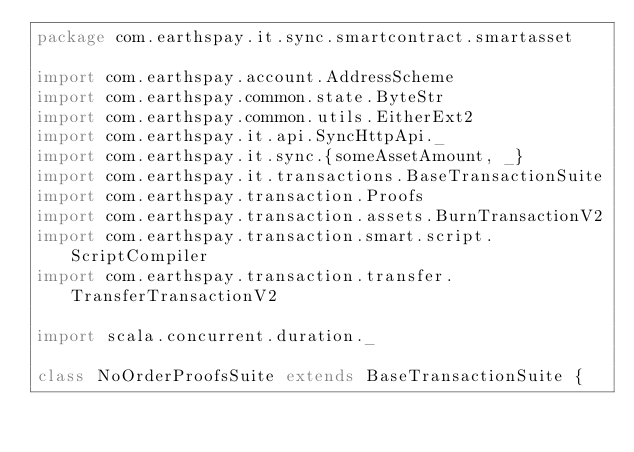Convert code to text. <code><loc_0><loc_0><loc_500><loc_500><_Scala_>package com.earthspay.it.sync.smartcontract.smartasset

import com.earthspay.account.AddressScheme
import com.earthspay.common.state.ByteStr
import com.earthspay.common.utils.EitherExt2
import com.earthspay.it.api.SyncHttpApi._
import com.earthspay.it.sync.{someAssetAmount, _}
import com.earthspay.it.transactions.BaseTransactionSuite
import com.earthspay.transaction.Proofs
import com.earthspay.transaction.assets.BurnTransactionV2
import com.earthspay.transaction.smart.script.ScriptCompiler
import com.earthspay.transaction.transfer.TransferTransactionV2

import scala.concurrent.duration._

class NoOrderProofsSuite extends BaseTransactionSuite {</code> 